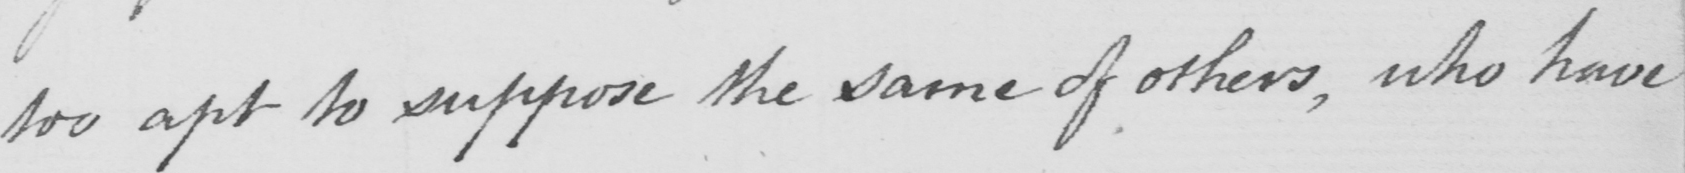What text is written in this handwritten line? too apt to suppose the same of others , who have 